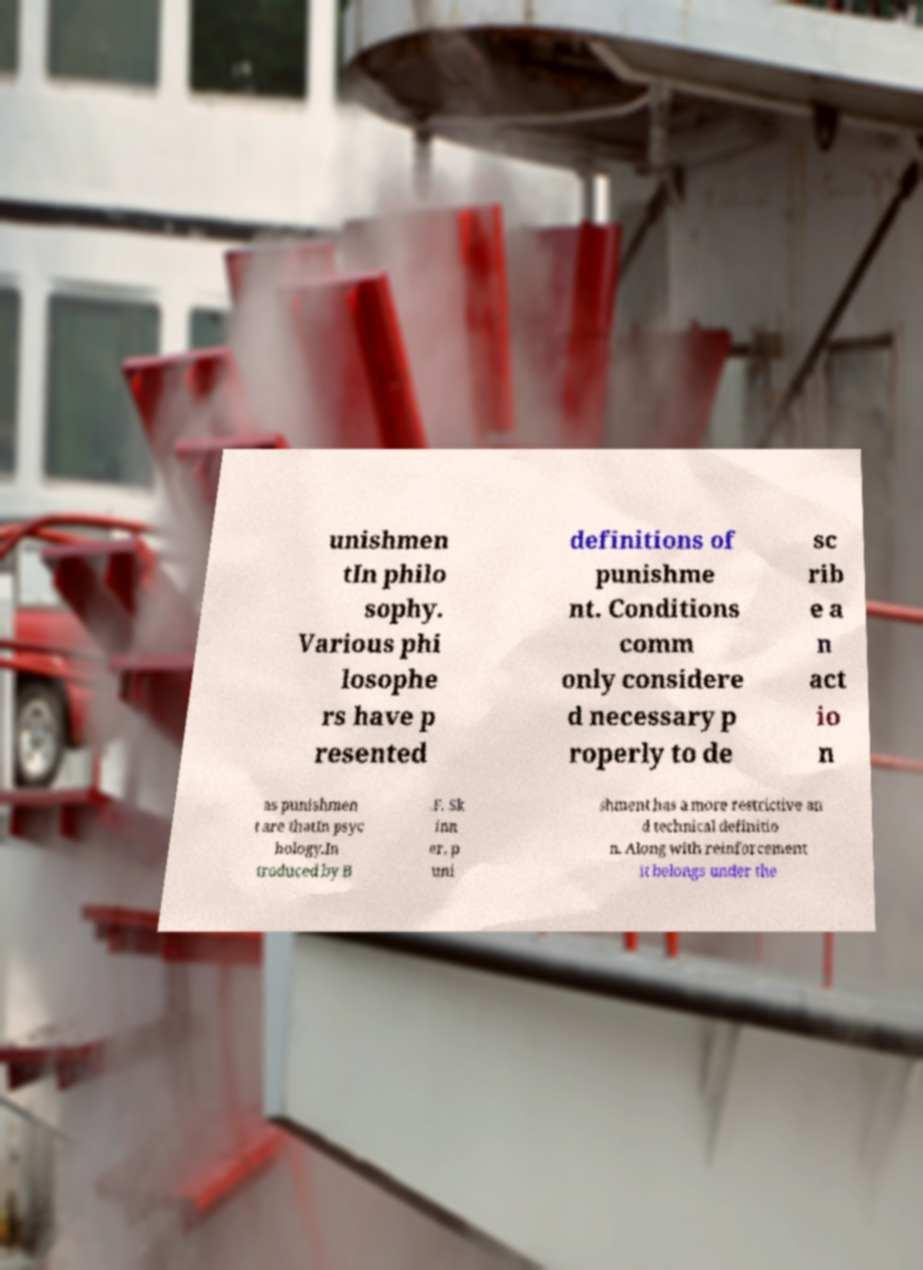I need the written content from this picture converted into text. Can you do that? unishmen tIn philo sophy. Various phi losophe rs have p resented definitions of punishme nt. Conditions comm only considere d necessary p roperly to de sc rib e a n act io n as punishmen t are thatIn psyc hology.In troduced by B .F. Sk inn er, p uni shment has a more restrictive an d technical definitio n. Along with reinforcement it belongs under the 